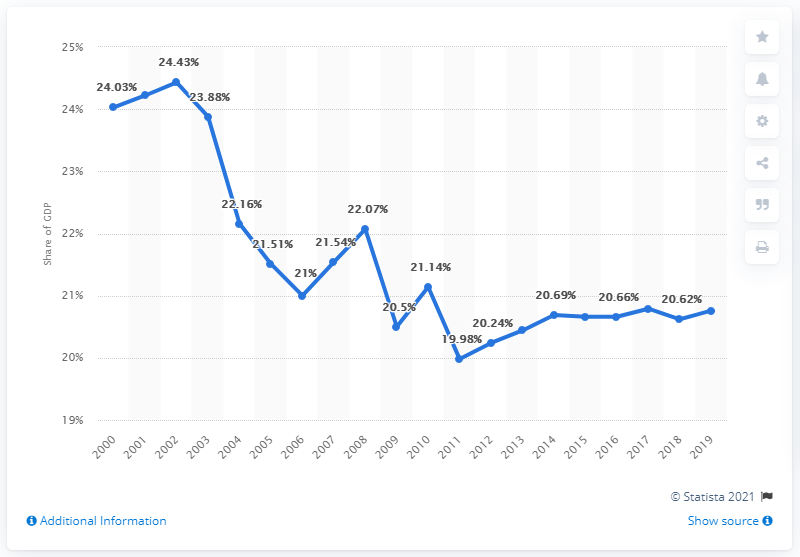Outline some significant characteristics in this image. In 2002, imports accounted for 24.4 percent of the country's GDP. In 2019, the import of goods and services accounted for nearly 21.14% of the Russian Gross Domestic Product (GDP). In 2002, imports accounted for 24.43% of Russia's total Gross Domestic Product (GDP). 